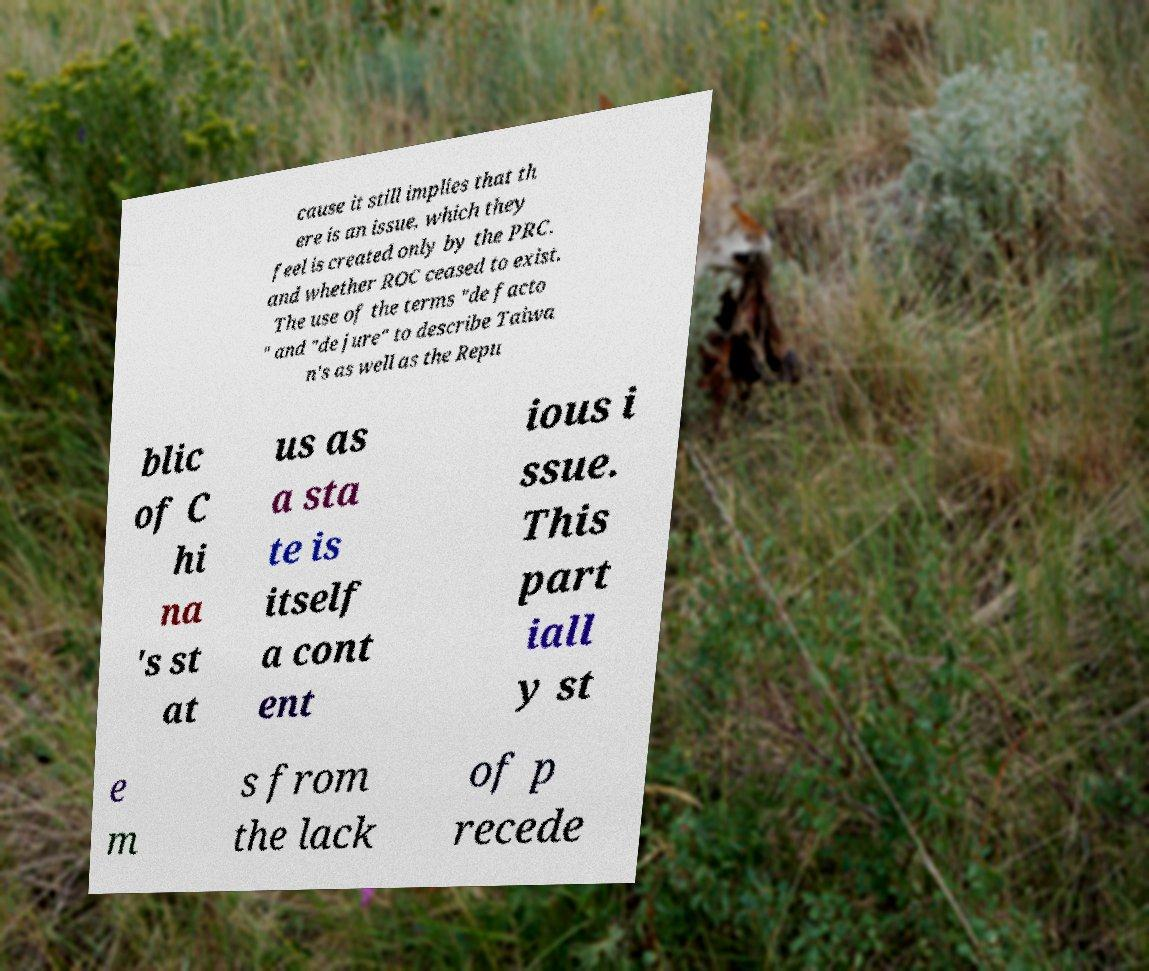Can you read and provide the text displayed in the image?This photo seems to have some interesting text. Can you extract and type it out for me? cause it still implies that th ere is an issue, which they feel is created only by the PRC. and whether ROC ceased to exist. The use of the terms "de facto " and "de jure" to describe Taiwa n's as well as the Repu blic of C hi na 's st at us as a sta te is itself a cont ent ious i ssue. This part iall y st e m s from the lack of p recede 